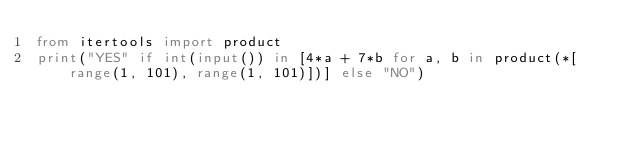<code> <loc_0><loc_0><loc_500><loc_500><_Python_>from itertools import product
print("YES" if int(input()) in [4*a + 7*b for a, b in product(*[range(1, 101), range(1, 101)])] else "NO")</code> 